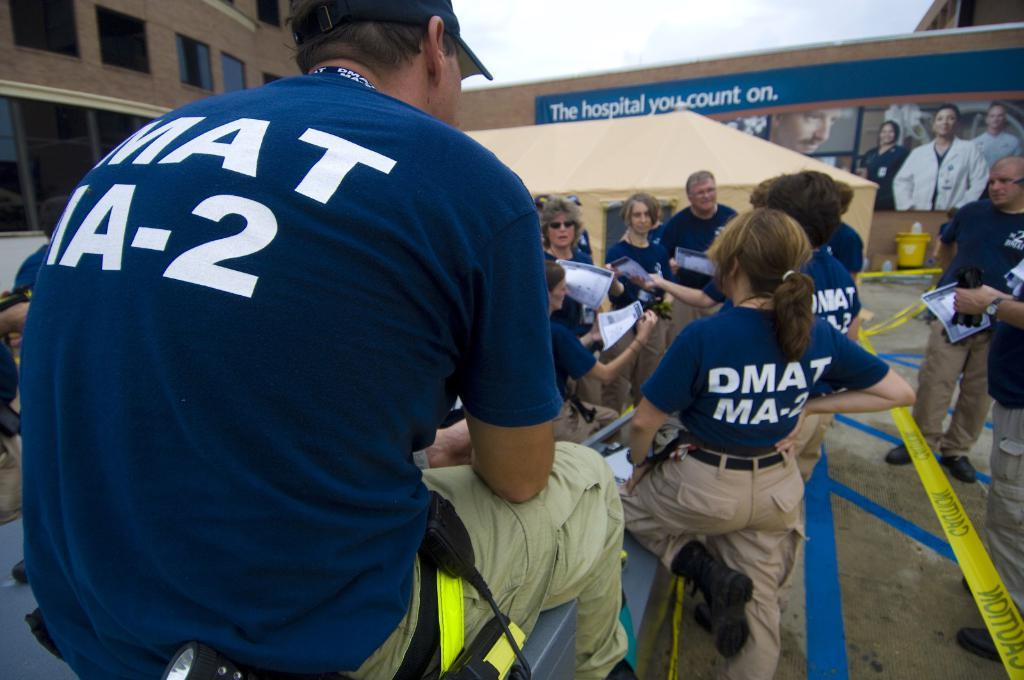Provide a one-sentence caption for the provided image. A group of people talk and socialize in front of a large outdoor advertisement which reads "The hospital you count on". 